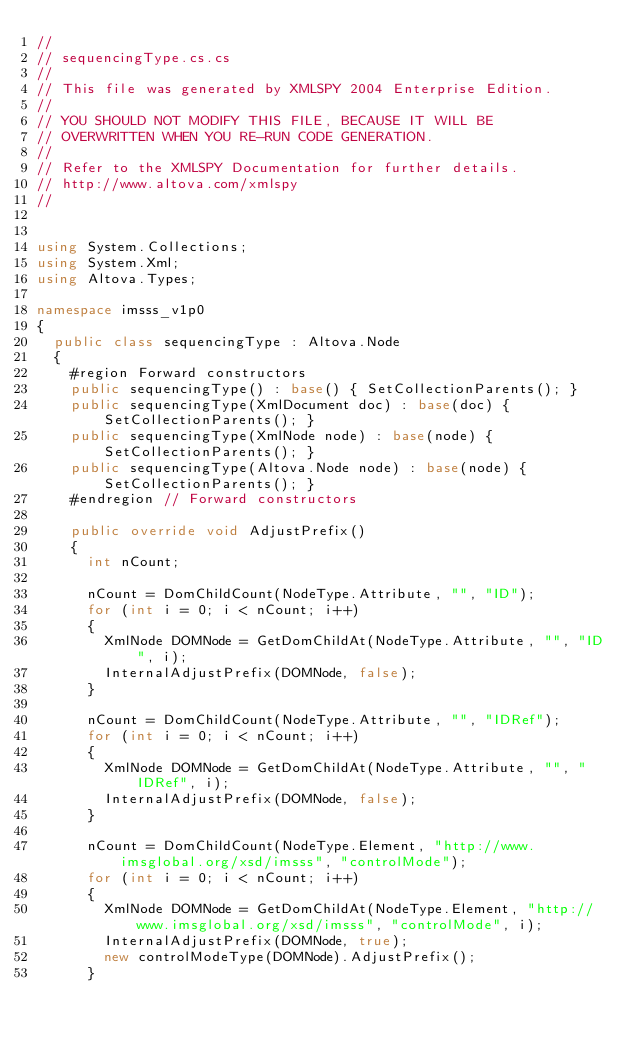<code> <loc_0><loc_0><loc_500><loc_500><_C#_>//
// sequencingType.cs.cs
//
// This file was generated by XMLSPY 2004 Enterprise Edition.
//
// YOU SHOULD NOT MODIFY THIS FILE, BECAUSE IT WILL BE
// OVERWRITTEN WHEN YOU RE-RUN CODE GENERATION.
//
// Refer to the XMLSPY Documentation for further details.
// http://www.altova.com/xmlspy
//


using System.Collections;
using System.Xml;
using Altova.Types;

namespace imsss_v1p0
{
	public class sequencingType : Altova.Node
	{
		#region Forward constructors
		public sequencingType() : base() { SetCollectionParents(); }
		public sequencingType(XmlDocument doc) : base(doc) { SetCollectionParents(); }
		public sequencingType(XmlNode node) : base(node) { SetCollectionParents(); }
		public sequencingType(Altova.Node node) : base(node) { SetCollectionParents(); }
		#endregion // Forward constructors

		public override void AdjustPrefix()
		{
			int nCount;

			nCount = DomChildCount(NodeType.Attribute, "", "ID");
			for (int i = 0; i < nCount; i++)
			{
				XmlNode DOMNode = GetDomChildAt(NodeType.Attribute, "", "ID", i);
				InternalAdjustPrefix(DOMNode, false);
			}

			nCount = DomChildCount(NodeType.Attribute, "", "IDRef");
			for (int i = 0; i < nCount; i++)
			{
				XmlNode DOMNode = GetDomChildAt(NodeType.Attribute, "", "IDRef", i);
				InternalAdjustPrefix(DOMNode, false);
			}

			nCount = DomChildCount(NodeType.Element, "http://www.imsglobal.org/xsd/imsss", "controlMode");
			for (int i = 0; i < nCount; i++)
			{
				XmlNode DOMNode = GetDomChildAt(NodeType.Element, "http://www.imsglobal.org/xsd/imsss", "controlMode", i);
				InternalAdjustPrefix(DOMNode, true);
				new controlModeType(DOMNode).AdjustPrefix();
			}
</code> 